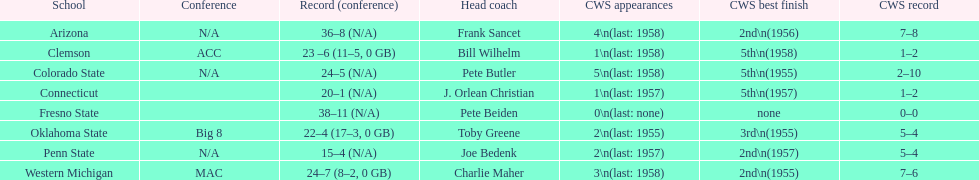Identify the schools that achieved the lowest position in the cws best outcome. Clemson, Colorado State, Connecticut. 